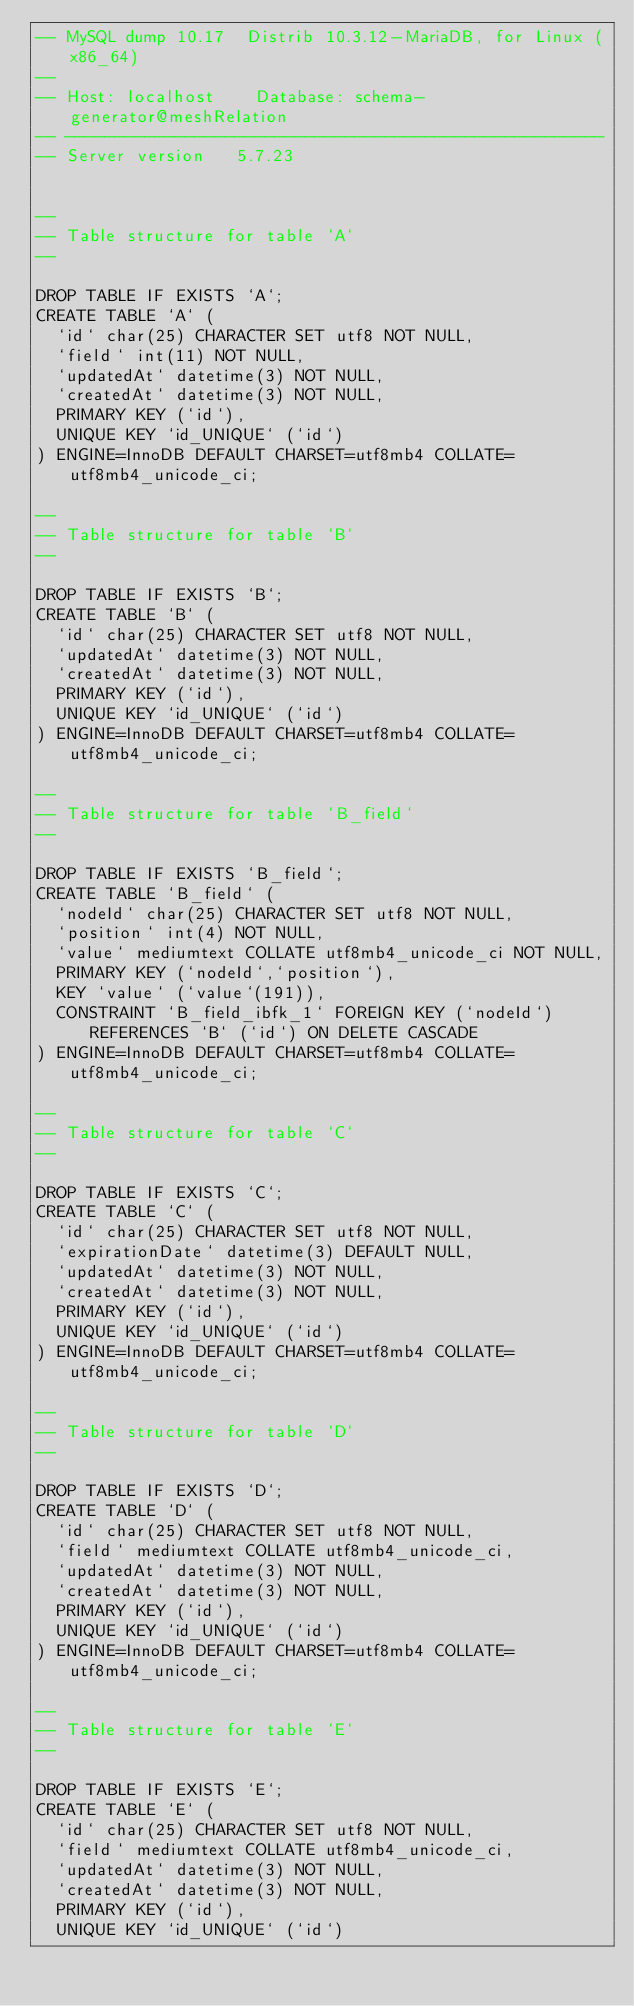<code> <loc_0><loc_0><loc_500><loc_500><_SQL_>-- MySQL dump 10.17  Distrib 10.3.12-MariaDB, for Linux (x86_64)
--
-- Host: localhost    Database: schema-generator@meshRelation
-- ------------------------------------------------------
-- Server version	5.7.23


--
-- Table structure for table `A`
--

DROP TABLE IF EXISTS `A`;
CREATE TABLE `A` (
  `id` char(25) CHARACTER SET utf8 NOT NULL,
  `field` int(11) NOT NULL,
  `updatedAt` datetime(3) NOT NULL,
  `createdAt` datetime(3) NOT NULL,
  PRIMARY KEY (`id`),
  UNIQUE KEY `id_UNIQUE` (`id`)
) ENGINE=InnoDB DEFAULT CHARSET=utf8mb4 COLLATE=utf8mb4_unicode_ci;

--
-- Table structure for table `B`
--

DROP TABLE IF EXISTS `B`;
CREATE TABLE `B` (
  `id` char(25) CHARACTER SET utf8 NOT NULL,
  `updatedAt` datetime(3) NOT NULL,
  `createdAt` datetime(3) NOT NULL,
  PRIMARY KEY (`id`),
  UNIQUE KEY `id_UNIQUE` (`id`)
) ENGINE=InnoDB DEFAULT CHARSET=utf8mb4 COLLATE=utf8mb4_unicode_ci;

--
-- Table structure for table `B_field`
--

DROP TABLE IF EXISTS `B_field`;
CREATE TABLE `B_field` (
  `nodeId` char(25) CHARACTER SET utf8 NOT NULL,
  `position` int(4) NOT NULL,
  `value` mediumtext COLLATE utf8mb4_unicode_ci NOT NULL,
  PRIMARY KEY (`nodeId`,`position`),
  KEY `value` (`value`(191)),
  CONSTRAINT `B_field_ibfk_1` FOREIGN KEY (`nodeId`) REFERENCES `B` (`id`) ON DELETE CASCADE
) ENGINE=InnoDB DEFAULT CHARSET=utf8mb4 COLLATE=utf8mb4_unicode_ci;

--
-- Table structure for table `C`
--

DROP TABLE IF EXISTS `C`;
CREATE TABLE `C` (
  `id` char(25) CHARACTER SET utf8 NOT NULL,
  `expirationDate` datetime(3) DEFAULT NULL,
  `updatedAt` datetime(3) NOT NULL,
  `createdAt` datetime(3) NOT NULL,
  PRIMARY KEY (`id`),
  UNIQUE KEY `id_UNIQUE` (`id`)
) ENGINE=InnoDB DEFAULT CHARSET=utf8mb4 COLLATE=utf8mb4_unicode_ci;

--
-- Table structure for table `D`
--

DROP TABLE IF EXISTS `D`;
CREATE TABLE `D` (
  `id` char(25) CHARACTER SET utf8 NOT NULL,
  `field` mediumtext COLLATE utf8mb4_unicode_ci,
  `updatedAt` datetime(3) NOT NULL,
  `createdAt` datetime(3) NOT NULL,
  PRIMARY KEY (`id`),
  UNIQUE KEY `id_UNIQUE` (`id`)
) ENGINE=InnoDB DEFAULT CHARSET=utf8mb4 COLLATE=utf8mb4_unicode_ci;

--
-- Table structure for table `E`
--

DROP TABLE IF EXISTS `E`;
CREATE TABLE `E` (
  `id` char(25) CHARACTER SET utf8 NOT NULL,
  `field` mediumtext COLLATE utf8mb4_unicode_ci,
  `updatedAt` datetime(3) NOT NULL,
  `createdAt` datetime(3) NOT NULL,
  PRIMARY KEY (`id`),
  UNIQUE KEY `id_UNIQUE` (`id`)</code> 